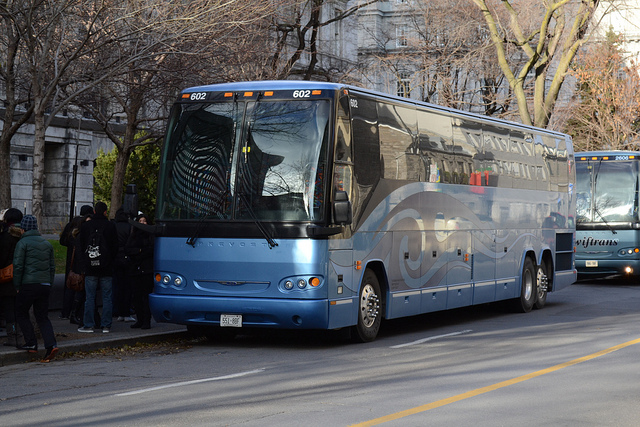What can you say about the people boarding the bus? There are a few people visible who appear to be boarding the bus. They are dressed in cold weather clothing, supporting the idea that the photo was taken in a cooler season. Their casual attire suggests that they might be travelers or commuters about to embark on a journey. 